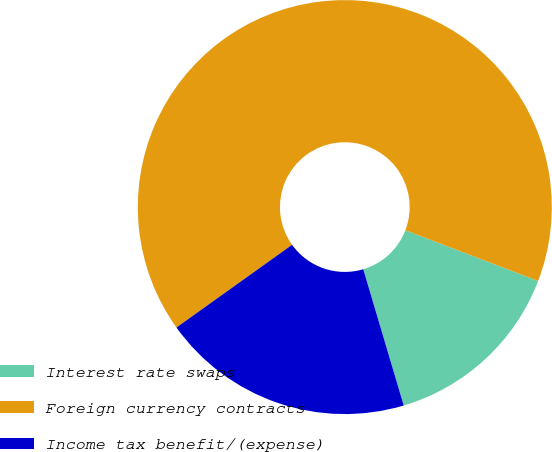<chart> <loc_0><loc_0><loc_500><loc_500><pie_chart><fcel>Interest rate swaps<fcel>Foreign currency contracts<fcel>Income tax benefit/(expense)<nl><fcel>14.6%<fcel>65.69%<fcel>19.71%<nl></chart> 